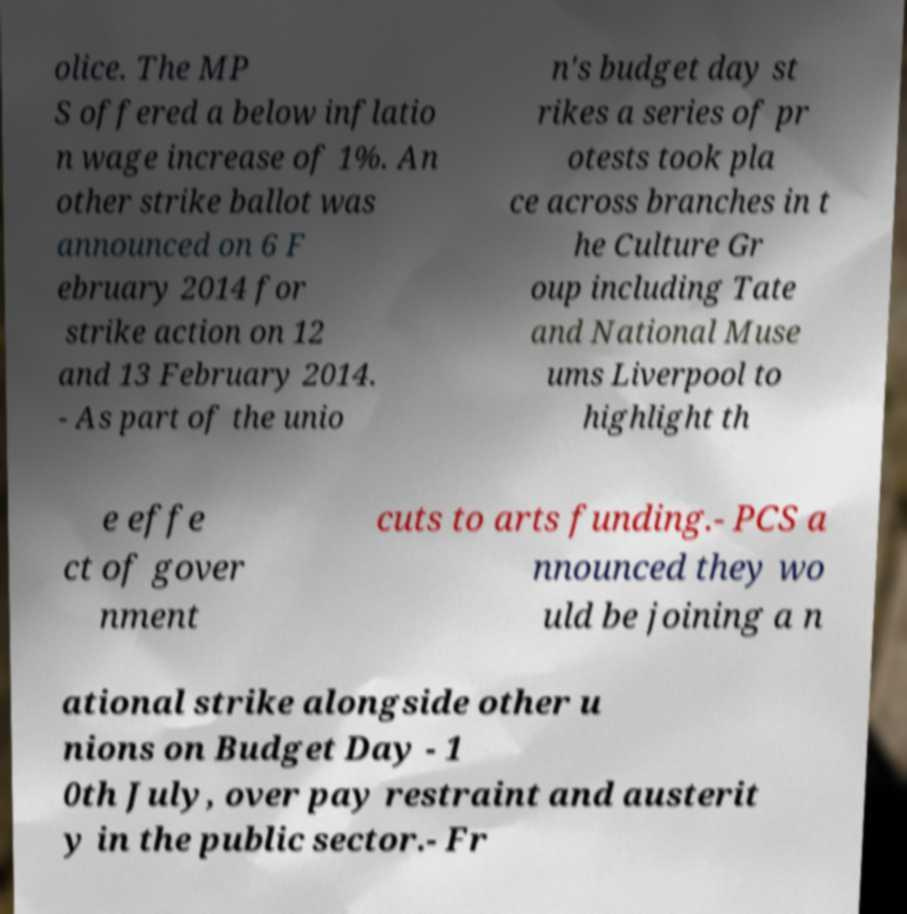There's text embedded in this image that I need extracted. Can you transcribe it verbatim? olice. The MP S offered a below inflatio n wage increase of 1%. An other strike ballot was announced on 6 F ebruary 2014 for strike action on 12 and 13 February 2014. - As part of the unio n's budget day st rikes a series of pr otests took pla ce across branches in t he Culture Gr oup including Tate and National Muse ums Liverpool to highlight th e effe ct of gover nment cuts to arts funding.- PCS a nnounced they wo uld be joining a n ational strike alongside other u nions on Budget Day - 1 0th July, over pay restraint and austerit y in the public sector.- Fr 